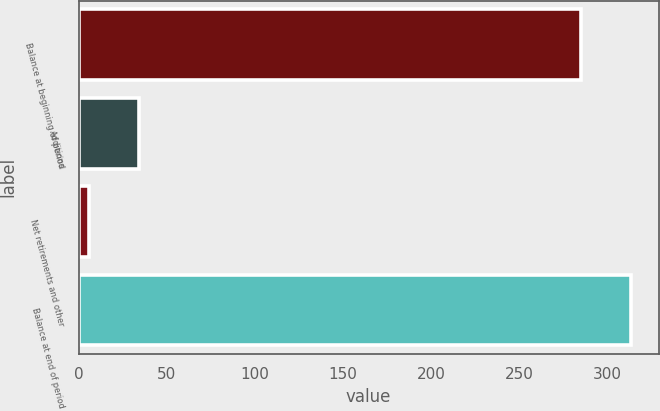Convert chart to OTSL. <chart><loc_0><loc_0><loc_500><loc_500><bar_chart><fcel>Balance at beginning of period<fcel>Additions<fcel>Net retirements and other<fcel>Balance at end of period<nl><fcel>285<fcel>34.5<fcel>6<fcel>313.5<nl></chart> 